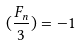Convert formula to latex. <formula><loc_0><loc_0><loc_500><loc_500>( \frac { F _ { n } } { 3 } ) = - 1</formula> 